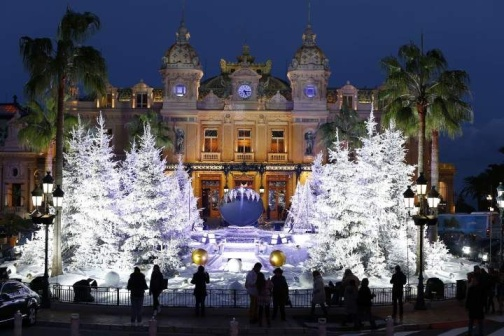Imagine a grand evening ball is held in this scene. Describe the event. The grand evening ball commenced with dignitaries from all corners of the world arriving at the palatial venue. The building's lights provided a warm, welcoming glow, setting the scene for an unforgettable night. The fountain, adorned with shimmering Christmas lights, served as a glamorous backdrop. Elegant guests in beautifully tailored gowns and tuxedos strolled around, engaging in conversations and admiring the festive decorations. The air was filled with the soft melody of a live orchestra playing classical tunes. Servers dressed in crisp uniforms moved gracefully among the guests, offering exquisite hors d'oeuvres and champagne. The ball was a perfect blend of sophistication, elegance, and celebration, capturing the essence of a timeless night. The night sky is clear, the air crisp, as the first notes of a waltz signal the commencement of the grand ball. Attendees in their finest attire glide across the dance floor set in front of the illuminated building. The stillness of the fountain's water, reflecting the twinkling lights, adds a magical charm to the celebration. Conversations buzz with excitement, laughter floats through the air, and the scent of blooming flowers intermingles with mouthwatering aromas from the gourmet feast prepared for the guests. It's an evening of enchantment, where the charisma of the holiday season meets the elegance of a regal celebration. 